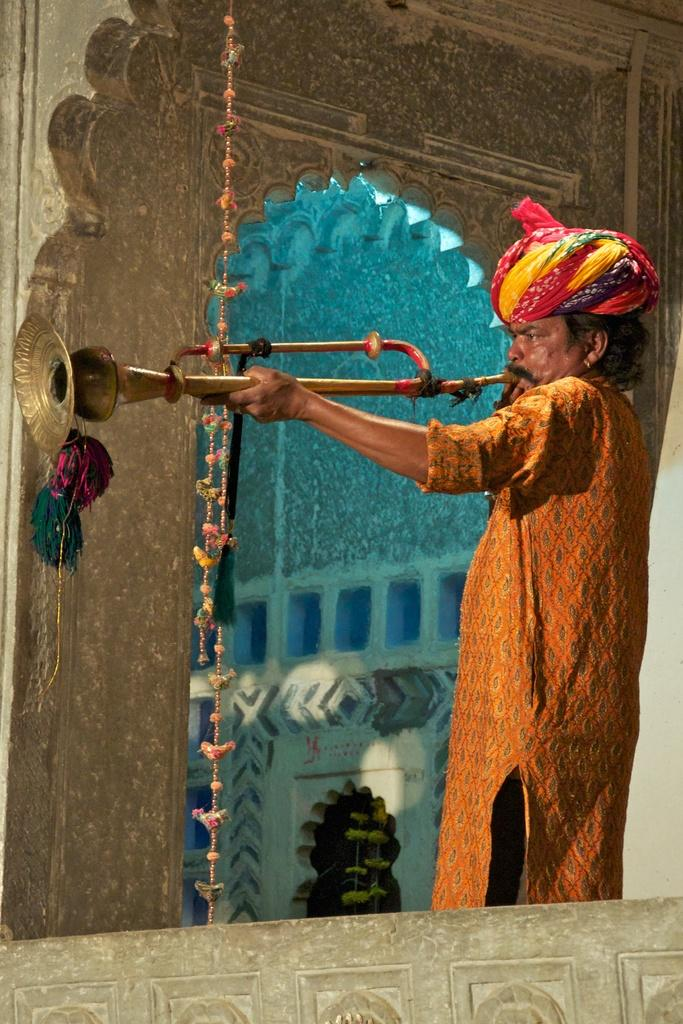What is the main subject of the image? There is a person in the image. What is the person holding in the image? The person is holding a clarinet. What can be seen in the background of the image? There is a wall in the background of the image. How many stars can be seen on the corn in the image? There are no stars or corn present in the image; it features a person holding a clarinet with a wall in the background. 